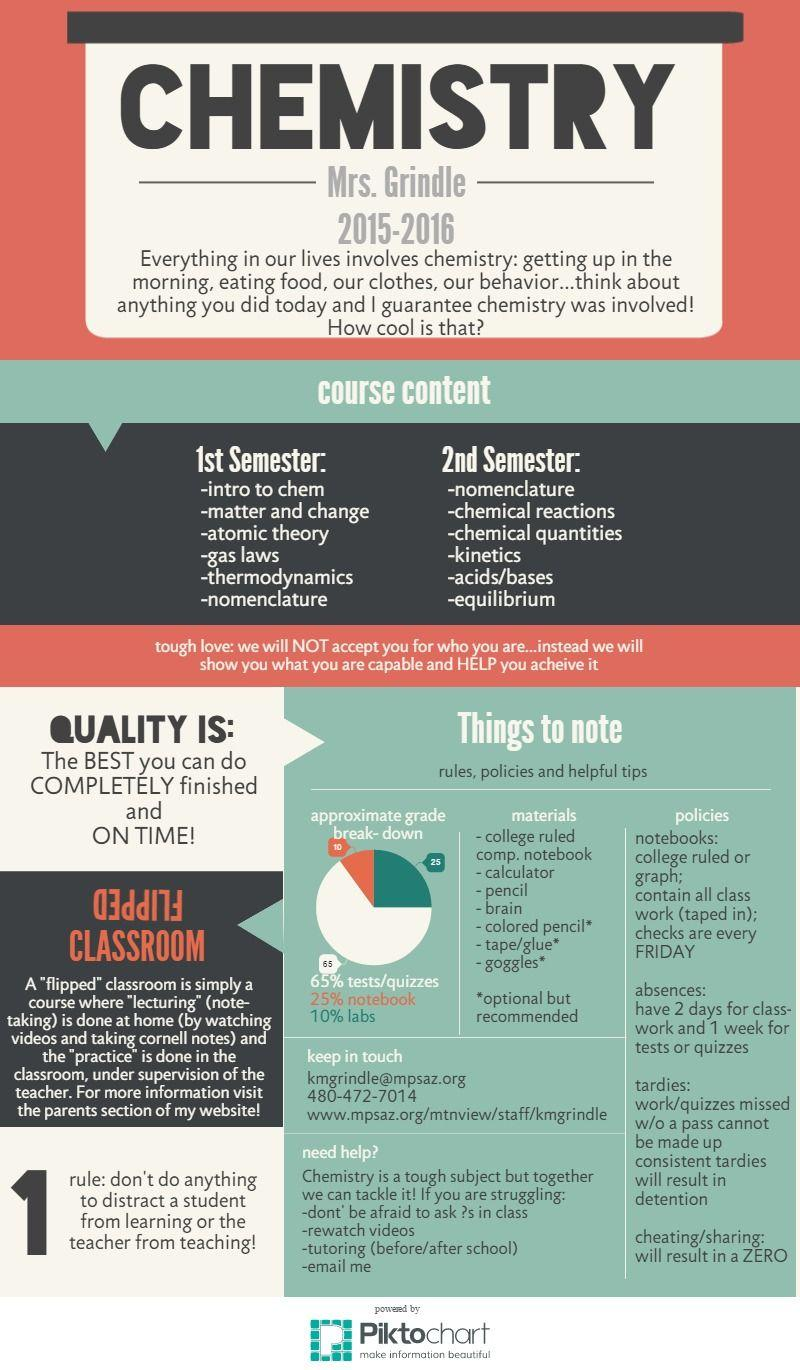Outline some significant characteristics in this image. The grade is determined by a combination of labs and notebooks, with 35% of the overall grade coming from both. The grade for classes is determined by a combination of tests and notebooks, with 90% of the overall grade coming from these assessments. 